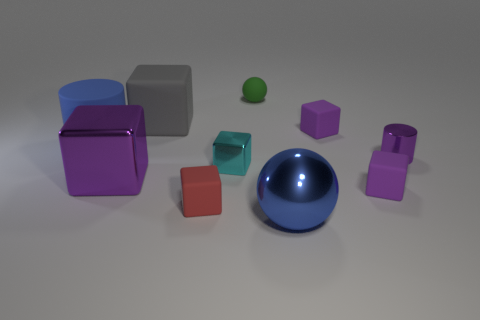Can you describe the texture visible on the surfaces of all the objects? Certainly! Each object displays a smooth and reflective texture that suggests they are made of a glossy material, possibly plastic or polished metal, which gives them a shiny appearance under the lighting conditions of their environment. 